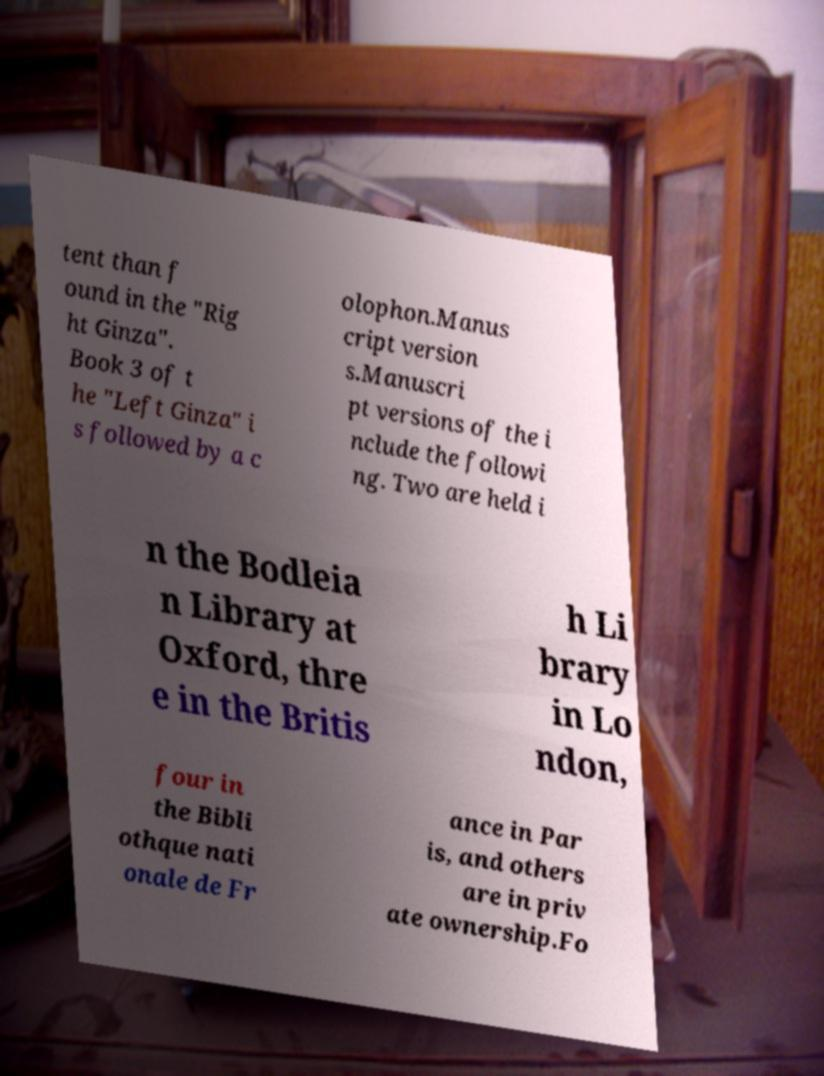Please read and relay the text visible in this image. What does it say? tent than f ound in the "Rig ht Ginza". Book 3 of t he "Left Ginza" i s followed by a c olophon.Manus cript version s.Manuscri pt versions of the i nclude the followi ng. Two are held i n the Bodleia n Library at Oxford, thre e in the Britis h Li brary in Lo ndon, four in the Bibli othque nati onale de Fr ance in Par is, and others are in priv ate ownership.Fo 